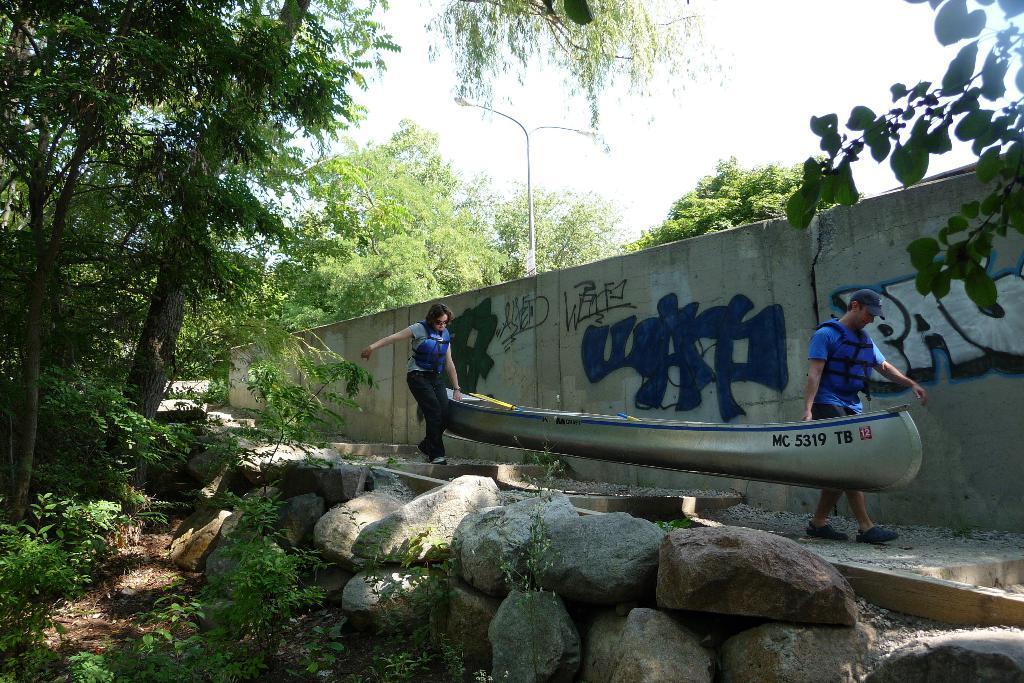How would you summarize this image in a sentence or two? In this image we can see two persons holding a boat and wearing life jackets, there are some rocks, plants, trees, and street light pole, also we can see the sky. 